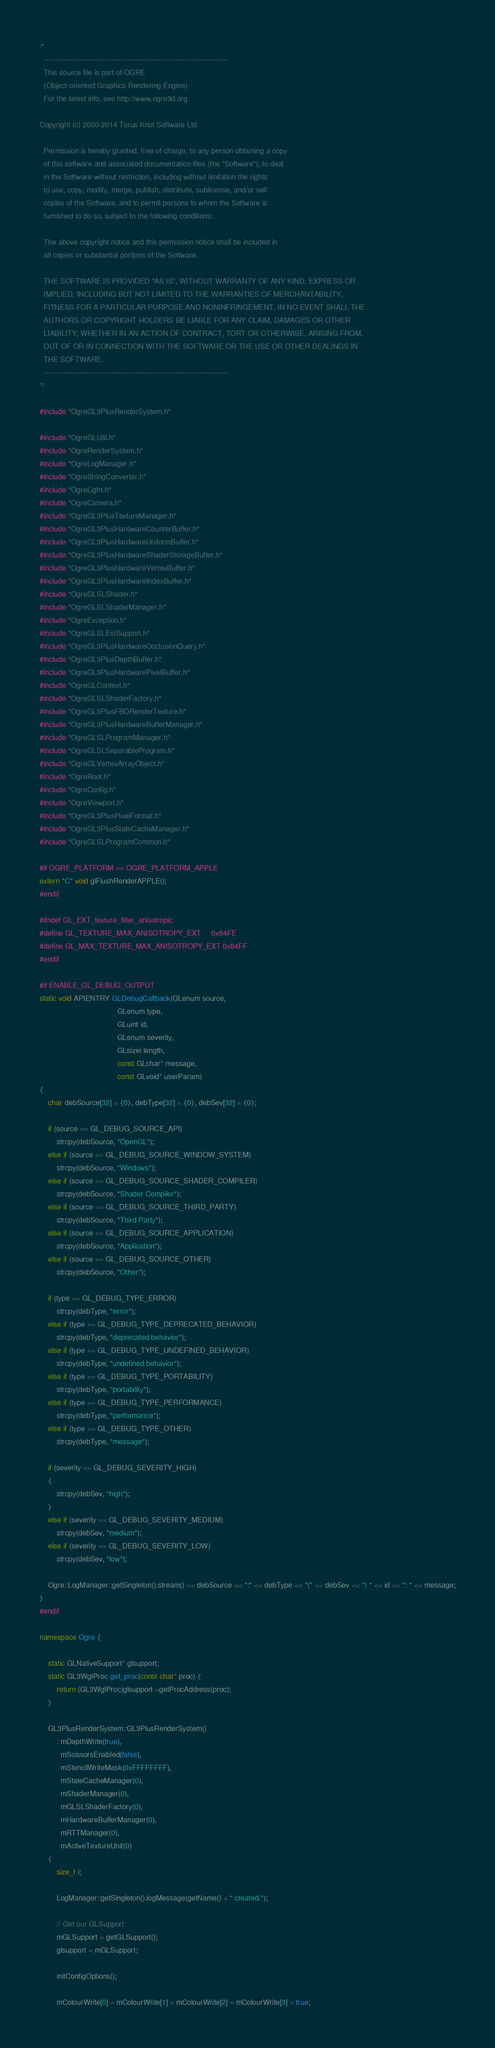Convert code to text. <code><loc_0><loc_0><loc_500><loc_500><_C++_>/*
  -----------------------------------------------------------------------------
  This source file is part of OGRE
  (Object-oriented Graphics Rendering Engine)
  For the latest info, see http://www.ogre3d.org

Copyright (c) 2000-2014 Torus Knot Software Ltd

  Permission is hereby granted, free of charge, to any person obtaining a copy
  of this software and associated documentation files (the "Software"), to deal
  in the Software without restriction, including without limitation the rights
  to use, copy, modify, merge, publish, distribute, sublicense, and/or sell
  copies of the Software, and to permit persons to whom the Software is
  furnished to do so, subject to the following conditions:

  The above copyright notice and this permission notice shall be included in
  all copies or substantial portions of the Software.

  THE SOFTWARE IS PROVIDED "AS IS", WITHOUT WARRANTY OF ANY KIND, EXPRESS OR
  IMPLIED, INCLUDING BUT NOT LIMITED TO THE WARRANTIES OF MERCHANTABILITY,
  FITNESS FOR A PARTICULAR PURPOSE AND NONINFRINGEMENT. IN NO EVENT SHALL THE
  AUTHORS OR COPYRIGHT HOLDERS BE LIABLE FOR ANY CLAIM, DAMAGES OR OTHER
  LIABILITY, WHETHER IN AN ACTION OF CONTRACT, TORT OR OTHERWISE, ARISING FROM,
  OUT OF OR IN CONNECTION WITH THE SOFTWARE OR THE USE OR OTHER DEALINGS IN
  THE SOFTWARE.
  -----------------------------------------------------------------------------
*/

#include "OgreGL3PlusRenderSystem.h"

#include "OgreGLUtil.h"
#include "OgreRenderSystem.h"
#include "OgreLogManager.h"
#include "OgreStringConverter.h"
#include "OgreLight.h"
#include "OgreCamera.h"
#include "OgreGL3PlusTextureManager.h"
#include "OgreGL3PlusHardwareCounterBuffer.h"
#include "OgreGL3PlusHardwareUniformBuffer.h"
#include "OgreGL3PlusHardwareShaderStorageBuffer.h"
#include "OgreGL3PlusHardwareVertexBuffer.h"
#include "OgreGL3PlusHardwareIndexBuffer.h"
#include "OgreGLSLShader.h"
#include "OgreGLSLShaderManager.h"
#include "OgreException.h"
#include "OgreGLSLExtSupport.h"
#include "OgreGL3PlusHardwareOcclusionQuery.h"
#include "OgreGL3PlusDepthBuffer.h"
#include "OgreGL3PlusHardwarePixelBuffer.h"
#include "OgreGLContext.h"
#include "OgreGLSLShaderFactory.h"
#include "OgreGL3PlusFBORenderTexture.h"
#include "OgreGL3PlusHardwareBufferManager.h"
#include "OgreGLSLProgramManager.h"
#include "OgreGLSLSeparableProgram.h"
#include "OgreGLVertexArrayObject.h"
#include "OgreRoot.h"
#include "OgreConfig.h"
#include "OgreViewport.h"
#include "OgreGL3PlusPixelFormat.h"
#include "OgreGL3PlusStateCacheManager.h"
#include "OgreGLSLProgramCommon.h"

#if OGRE_PLATFORM == OGRE_PLATFORM_APPLE
extern "C" void glFlushRenderAPPLE();
#endif

#ifndef GL_EXT_texture_filter_anisotropic
#define GL_TEXTURE_MAX_ANISOTROPY_EXT     0x84FE
#define GL_MAX_TEXTURE_MAX_ANISOTROPY_EXT 0x84FF
#endif

#if ENABLE_GL_DEBUG_OUTPUT
static void APIENTRY GLDebugCallback(GLenum source,
                                     GLenum type,
                                     GLuint id,
                                     GLenum severity,
                                     GLsizei length,
                                     const GLchar* message,
                                     const GLvoid* userParam)
{
    char debSource[32] = {0}, debType[32] = {0}, debSev[32] = {0};

    if (source == GL_DEBUG_SOURCE_API)
        strcpy(debSource, "OpenGL");
    else if (source == GL_DEBUG_SOURCE_WINDOW_SYSTEM)
        strcpy(debSource, "Windows");
    else if (source == GL_DEBUG_SOURCE_SHADER_COMPILER)
        strcpy(debSource, "Shader Compiler");
    else if (source == GL_DEBUG_SOURCE_THIRD_PARTY)
        strcpy(debSource, "Third Party");
    else if (source == GL_DEBUG_SOURCE_APPLICATION)
        strcpy(debSource, "Application");
    else if (source == GL_DEBUG_SOURCE_OTHER)
        strcpy(debSource, "Other");

    if (type == GL_DEBUG_TYPE_ERROR)
        strcpy(debType, "error");
    else if (type == GL_DEBUG_TYPE_DEPRECATED_BEHAVIOR)
        strcpy(debType, "deprecated behavior");
    else if (type == GL_DEBUG_TYPE_UNDEFINED_BEHAVIOR)
        strcpy(debType, "undefined behavior");
    else if (type == GL_DEBUG_TYPE_PORTABILITY)
        strcpy(debType, "portability");
    else if (type == GL_DEBUG_TYPE_PERFORMANCE)
        strcpy(debType, "performance");
    else if (type == GL_DEBUG_TYPE_OTHER)
        strcpy(debType, "message");

    if (severity == GL_DEBUG_SEVERITY_HIGH)
    {
        strcpy(debSev, "high");
    }
    else if (severity == GL_DEBUG_SEVERITY_MEDIUM)
        strcpy(debSev, "medium");
    else if (severity == GL_DEBUG_SEVERITY_LOW)
        strcpy(debSev, "low");

    Ogre::LogManager::getSingleton().stream() << debSource << ":" << debType << "(" << debSev << ") " << id << ": " << message;
}
#endif

namespace Ogre {

    static GLNativeSupport* glsupport;
    static GL3WglProc get_proc(const char* proc) {
        return (GL3WglProc)glsupport->getProcAddress(proc);
    }

    GL3PlusRenderSystem::GL3PlusRenderSystem()
        : mDepthWrite(true),
          mScissorsEnabled(false),
          mStencilWriteMask(0xFFFFFFFF),
          mStateCacheManager(0),
          mShaderManager(0),
          mGLSLShaderFactory(0),
          mHardwareBufferManager(0),
          mRTTManager(0),
          mActiveTextureUnit(0)
    {
        size_t i;

        LogManager::getSingleton().logMessage(getName() + " created.");

        // Get our GLSupport
        mGLSupport = getGLSupport();
        glsupport = mGLSupport;

        initConfigOptions();

        mColourWrite[0] = mColourWrite[1] = mColourWrite[2] = mColourWrite[3] = true;
</code> 